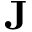<formula> <loc_0><loc_0><loc_500><loc_500>J</formula> 